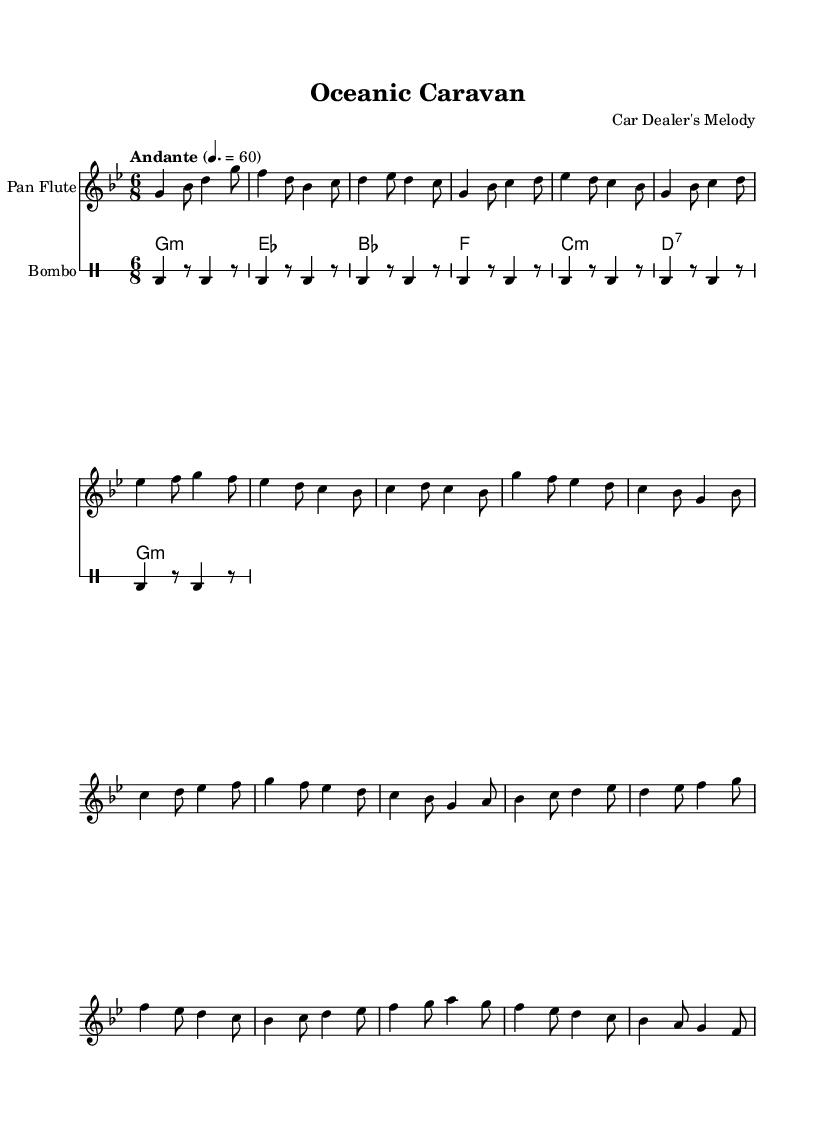What is the key signature of this music? The key signature is indicated at the beginning of the staff with one flat and corresponds to G minor, which has two flats.
Answer: G minor What is the time signature of this piece? The time signature is shown at the beginning of the music as a fraction which indicates six eighth notes per measure, meaning that the music is in compound meter.
Answer: 6/8 What is the tempo marking for this composition? The tempo marking is indicated above the staff and states that the piece should be played at a moderate pace, specifically 60 beats per minute, with a term suggesting a moderately slow tempo.
Answer: Andante How many main sections are present in the composition? By analyzing the structure of the sheet music, it can be inferred that there are three clear sections: Introduction, Verse, Chorus, and Bridge, resulting in a total of four distinct segments contributing to the overall composition structure.
Answer: Four What instruments are involved in this composition? The score specifies different instruments used throughout the arrangement, which are notably identified as the pan flute, charango, and bombo, each serving a unique role within the ensemble.
Answer: Pan Flute, Charango, Bombo Which section contains the most dynamic variations? By examining the musical scores, the Chorus section seems to exhibit the greatest range in dynamics due to the variation in the tonal quality and articulation present, contrasting between softer and louder passages.
Answer: Chorus 